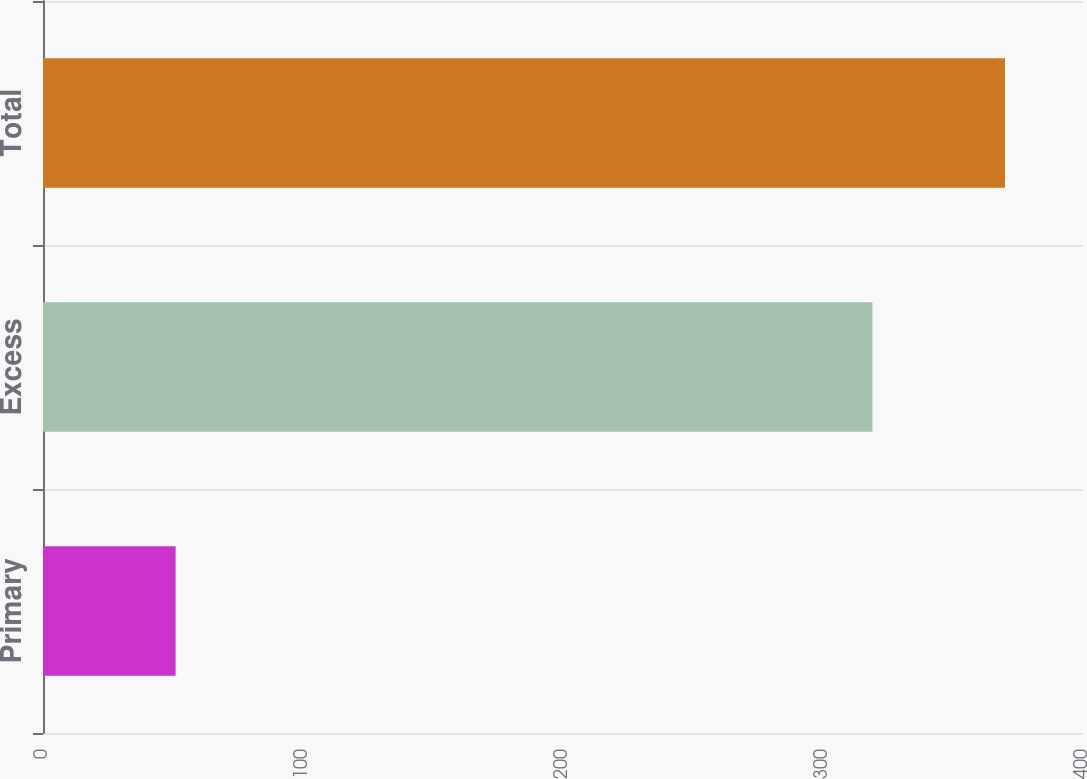<chart> <loc_0><loc_0><loc_500><loc_500><bar_chart><fcel>Primary<fcel>Excess<fcel>Total<nl><fcel>51<fcel>319<fcel>370<nl></chart> 